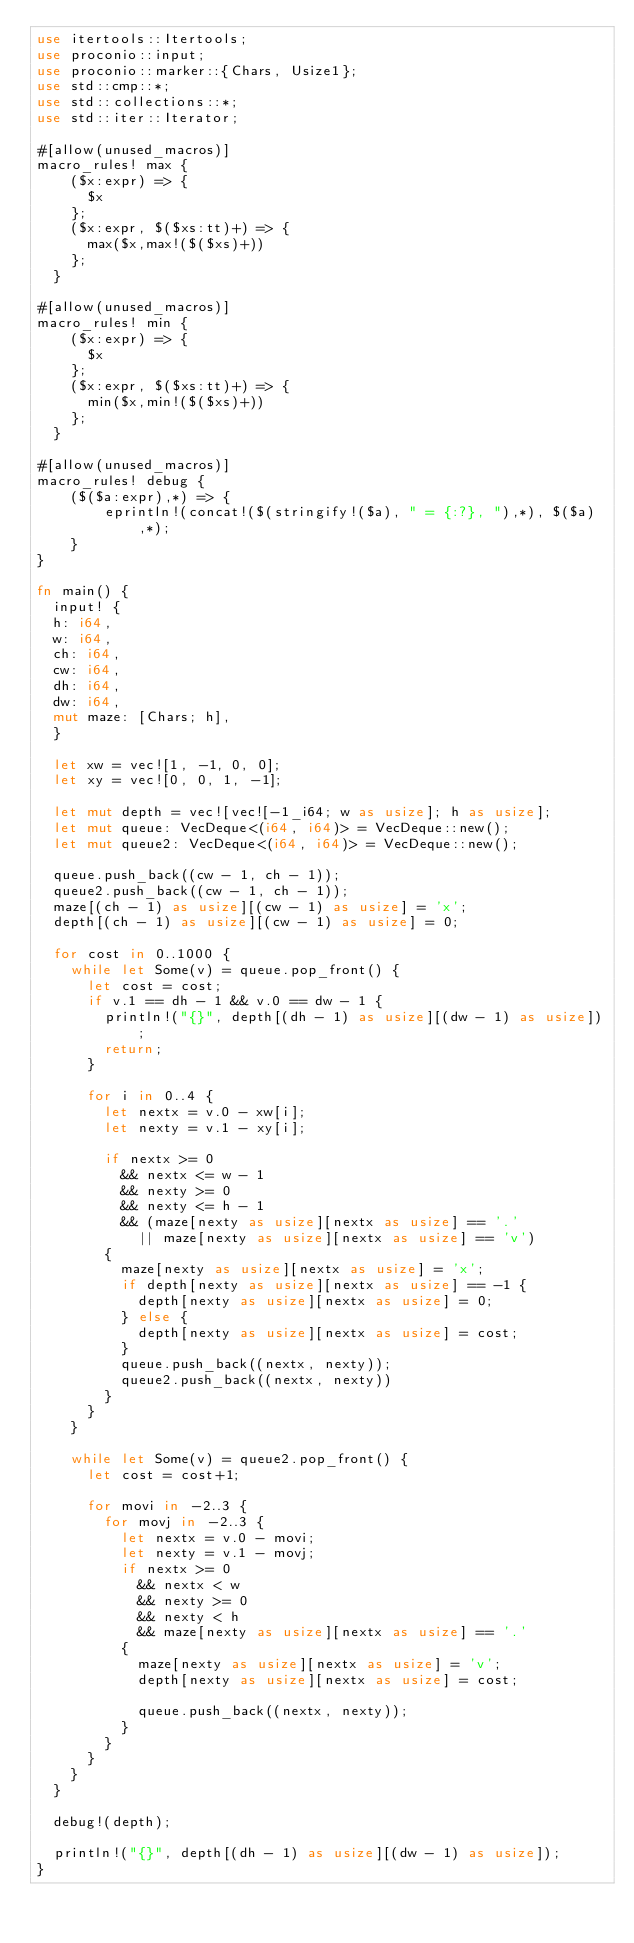Convert code to text. <code><loc_0><loc_0><loc_500><loc_500><_Rust_>use itertools::Itertools;
use proconio::input;
use proconio::marker::{Chars, Usize1};
use std::cmp::*;
use std::collections::*;
use std::iter::Iterator;

#[allow(unused_macros)]
macro_rules! max {
    ($x:expr) => {
      $x
    };
    ($x:expr, $($xs:tt)+) => {
      max($x,max!($($xs)+))
    };
  }

#[allow(unused_macros)]
macro_rules! min {
    ($x:expr) => {
      $x
    };
    ($x:expr, $($xs:tt)+) => {
      min($x,min!($($xs)+))
    };
  }

#[allow(unused_macros)]
macro_rules! debug {
    ($($a:expr),*) => {
        eprintln!(concat!($(stringify!($a), " = {:?}, "),*), $($a),*);
    }
}

fn main() {
  input! {
  h: i64,
  w: i64,
  ch: i64,
  cw: i64,
  dh: i64,
  dw: i64,
  mut maze: [Chars; h],
  }

  let xw = vec![1, -1, 0, 0];
  let xy = vec![0, 0, 1, -1];

  let mut depth = vec![vec![-1_i64; w as usize]; h as usize];
  let mut queue: VecDeque<(i64, i64)> = VecDeque::new();
  let mut queue2: VecDeque<(i64, i64)> = VecDeque::new();

  queue.push_back((cw - 1, ch - 1));
  queue2.push_back((cw - 1, ch - 1));
  maze[(ch - 1) as usize][(cw - 1) as usize] = 'x';
  depth[(ch - 1) as usize][(cw - 1) as usize] = 0;

  for cost in 0..1000 {
    while let Some(v) = queue.pop_front() {
      let cost = cost;
      if v.1 == dh - 1 && v.0 == dw - 1 {
        println!("{}", depth[(dh - 1) as usize][(dw - 1) as usize]);
        return;
      }

      for i in 0..4 {
        let nextx = v.0 - xw[i];
        let nexty = v.1 - xy[i];

        if nextx >= 0
          && nextx <= w - 1
          && nexty >= 0
          && nexty <= h - 1
          && (maze[nexty as usize][nextx as usize] == '.'
            || maze[nexty as usize][nextx as usize] == 'v')
        {
          maze[nexty as usize][nextx as usize] = 'x';
          if depth[nexty as usize][nextx as usize] == -1 {
            depth[nexty as usize][nextx as usize] = 0;
          } else {
            depth[nexty as usize][nextx as usize] = cost;
          }
          queue.push_back((nextx, nexty));
          queue2.push_back((nextx, nexty))
        }
      }
    }

    while let Some(v) = queue2.pop_front() {
      let cost = cost+1;

      for movi in -2..3 {
        for movj in -2..3 {
          let nextx = v.0 - movi;
          let nexty = v.1 - movj;
          if nextx >= 0
            && nextx < w
            && nexty >= 0
            && nexty < h
            && maze[nexty as usize][nextx as usize] == '.'
          {
            maze[nexty as usize][nextx as usize] = 'v';
            depth[nexty as usize][nextx as usize] = cost;

            queue.push_back((nextx, nexty));
          }
        }
      }
    }
  }

  debug!(depth);

  println!("{}", depth[(dh - 1) as usize][(dw - 1) as usize]);
}
</code> 